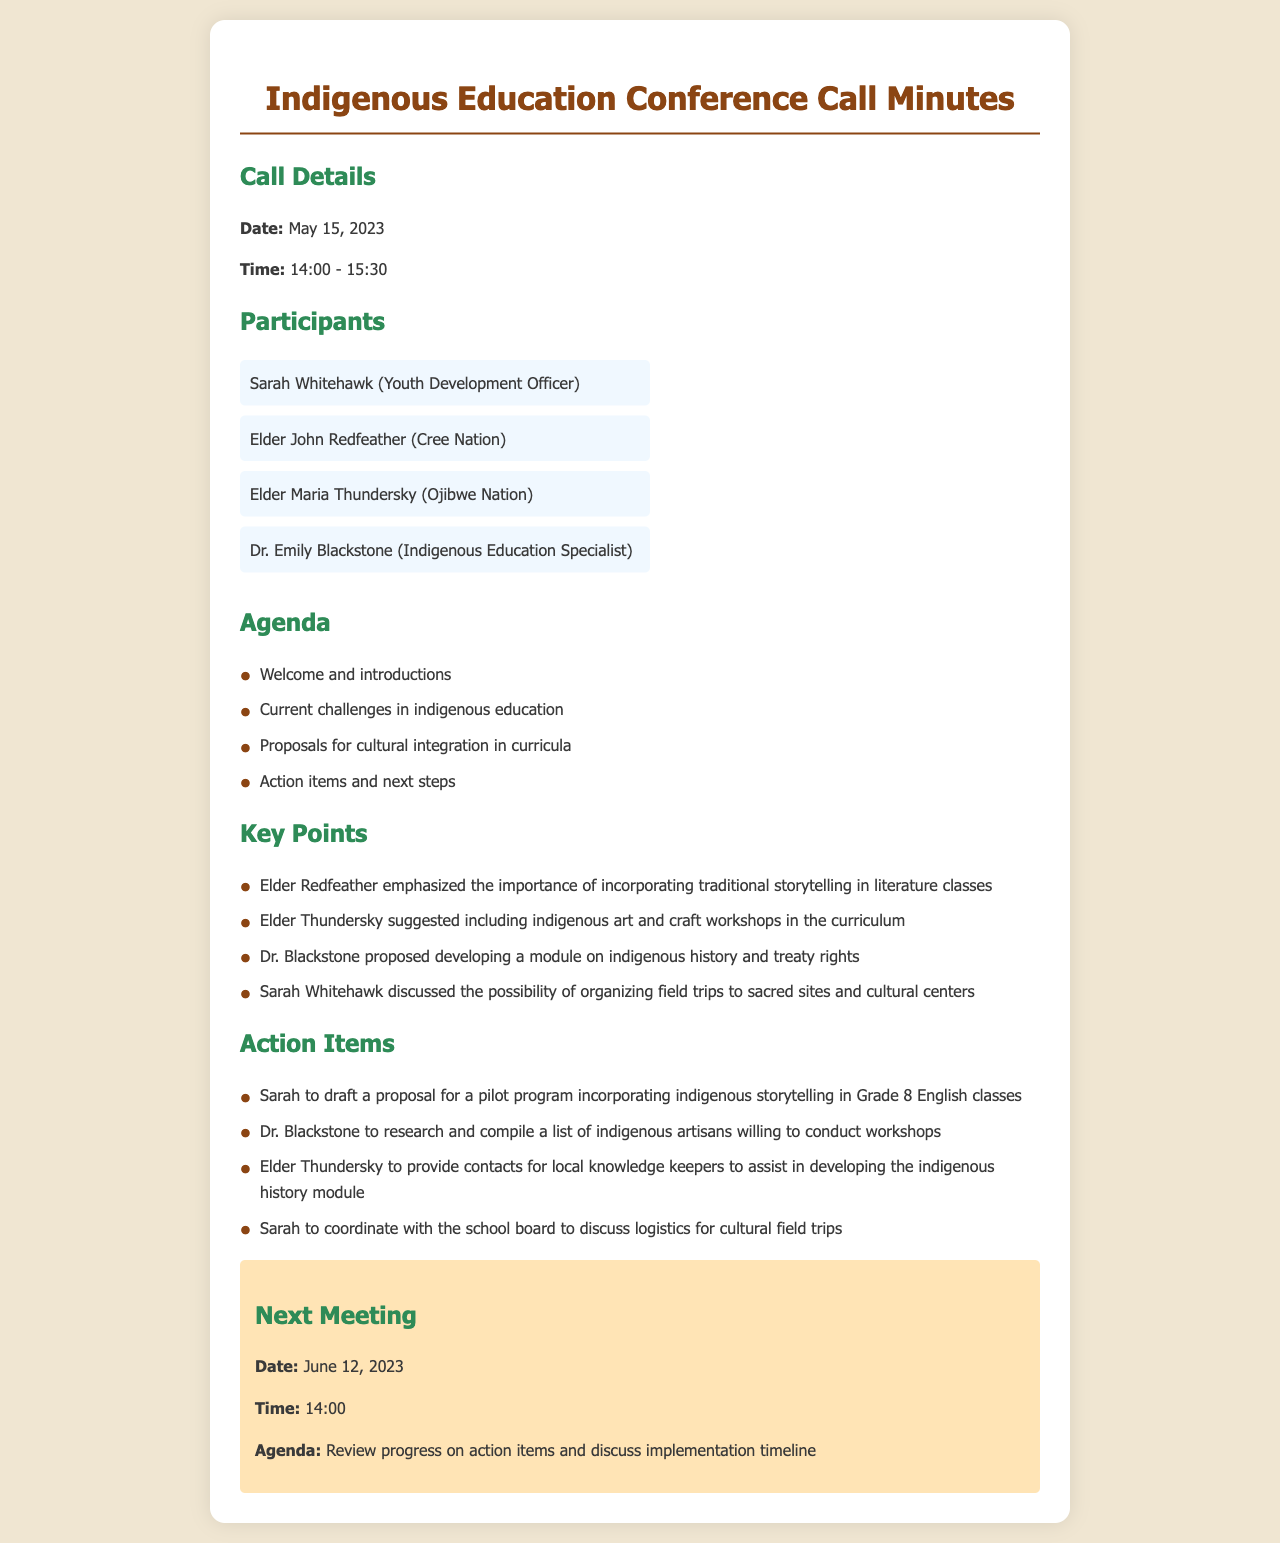What is the date of the call? The date of the call is stated at the beginning of the document.
Answer: May 15, 2023 Who suggested including indigenous art in the curriculum? This information is derived from the key points where participants' contributions are listed.
Answer: Elder Thundersky What time does the next meeting start? The time for the next meeting is provided in the "Next Meeting" section.
Answer: 14:00 What is one of the action items for Sarah? The action items are listed after the key points, specifying the tasks assigned to each participant.
Answer: Draft a proposal for a pilot program Which elder emphasized traditional storytelling? The significant points made by each elder are mentioned under key points.
Answer: Elder Redfeather How long was the conference call? The duration of the call is indicated in the call details section of the document.
Answer: 1 hour 30 minutes What is the agenda item related to indigenous history? The agenda includes specific topics that were to be discussed during the call.
Answer: Develop a module on indigenous history and treaty rights When is the next meeting scheduled? The date for the next meeting is mentioned in the "Next Meeting" section.
Answer: June 12, 2023 